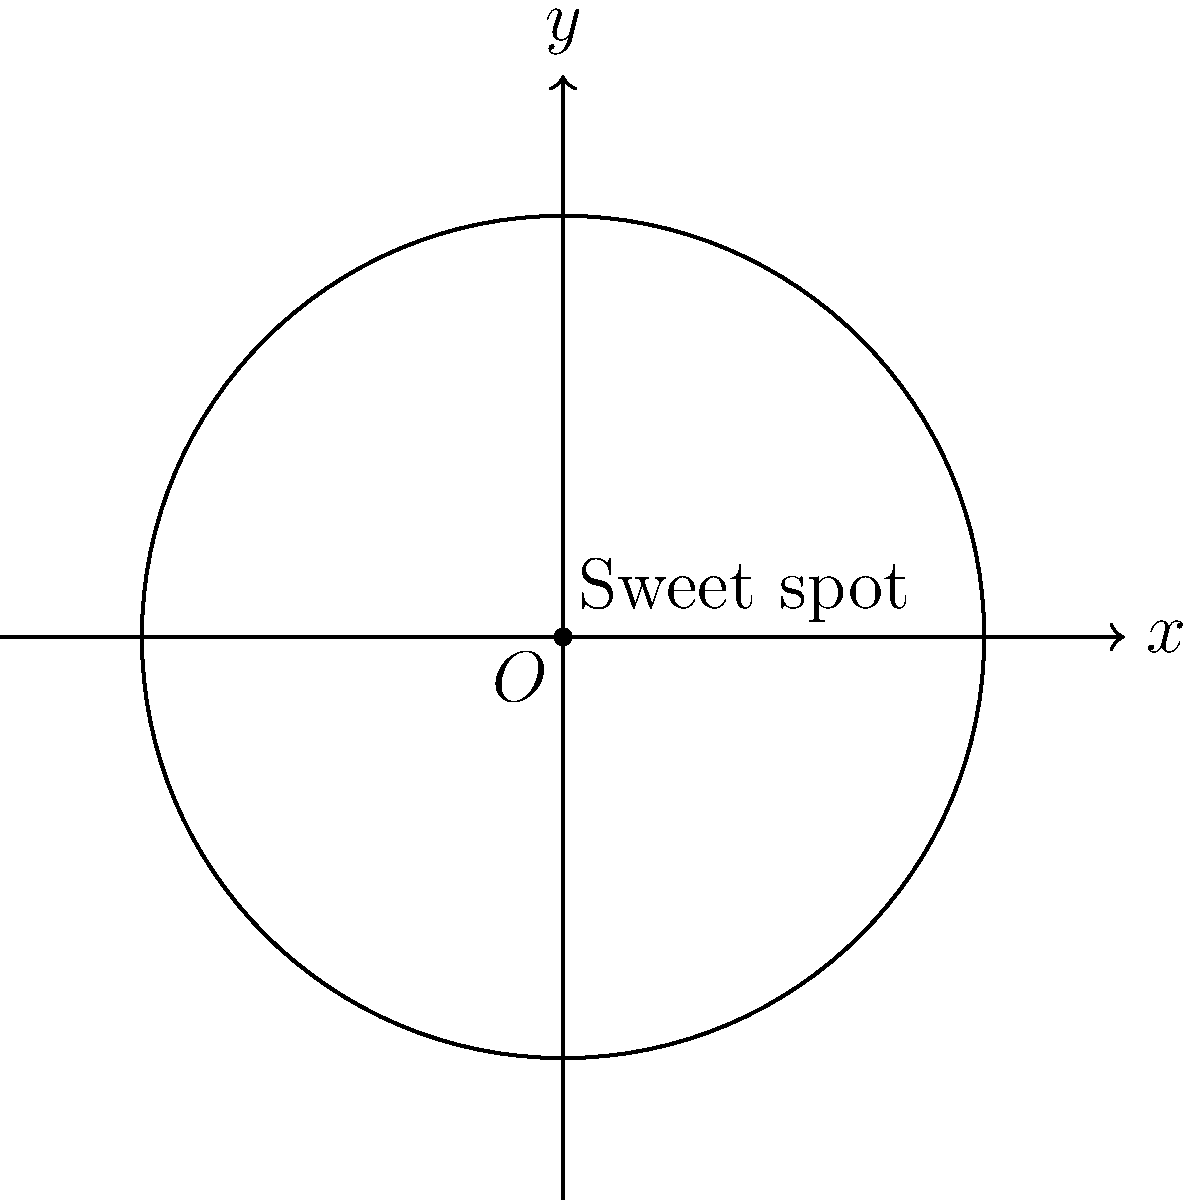At the Sheffield Arena, sound engineers have determined that the acoustic sweet spot in the concert hall can be modeled by a circle. The equation of this circle is given by $x^2 + y^2 = 9$, where the coordinates are measured in meters from the center of the hall. What is the area of this acoustic sweet spot? To find the area of the acoustic sweet spot, we need to follow these steps:

1) The general equation of a circle is $(x - h)^2 + (y - k)^2 = r^2$, where $(h,k)$ is the center and $r$ is the radius.

2) In our case, the equation is $x^2 + y^2 = 9$. Comparing this to the general form, we can see that:
   - The center is at $(0,0)$, which makes sense as we're measuring from the center of the hall.
   - The right side, 9, equals $r^2$.

3) To find the radius, we take the square root of both sides:
   $r = \sqrt{9} = 3$ meters

4) Now that we have the radius, we can calculate the area using the formula for the area of a circle:
   $A = \pi r^2$

5) Substituting our radius:
   $A = \pi (3)^2 = 9\pi$ square meters

Therefore, the area of the acoustic sweet spot is $9\pi$ square meters.
Answer: $9\pi$ m² 